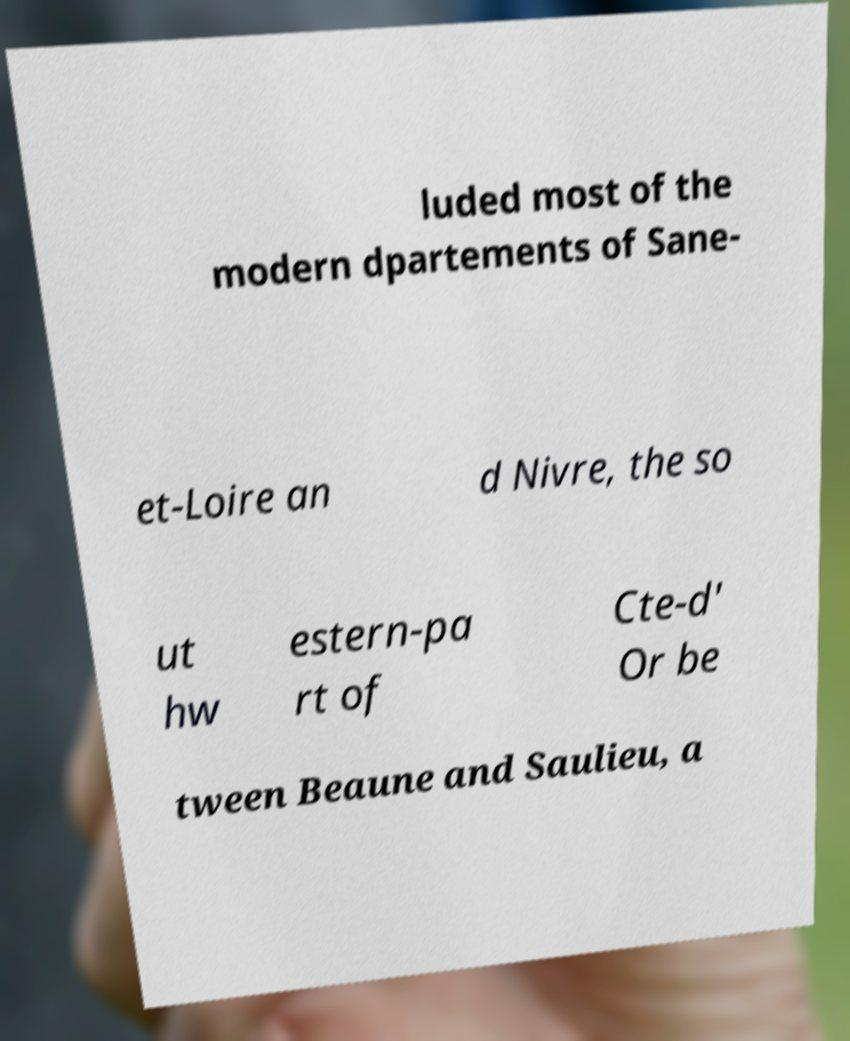Can you accurately transcribe the text from the provided image for me? luded most of the modern dpartements of Sane- et-Loire an d Nivre, the so ut hw estern-pa rt of Cte-d' Or be tween Beaune and Saulieu, a 